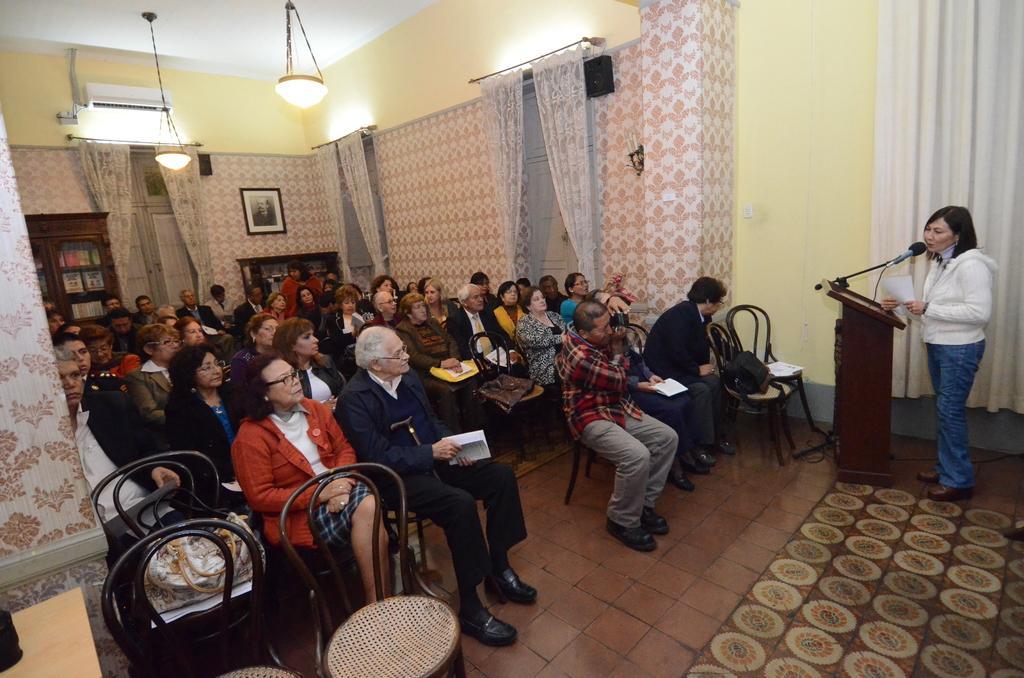Could you give a brief overview of what you see in this image? On the left side, there are persons in different color dresses, sitting on chairs and there is a curtain. Some of these persons are holding books. On the right side, there is a woman in a white color jacket, holding a paper, standing and speaking in front of a microphone, which is attached to a wooden stand. In the background, there are curtains, there are lights attached to a roof, a photo frame attached to a wall, there are two cupboards and a speaker. 